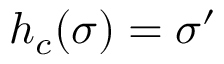Convert formula to latex. <formula><loc_0><loc_0><loc_500><loc_500>h _ { c } ( \sigma ) = \sigma ^ { \prime }</formula> 